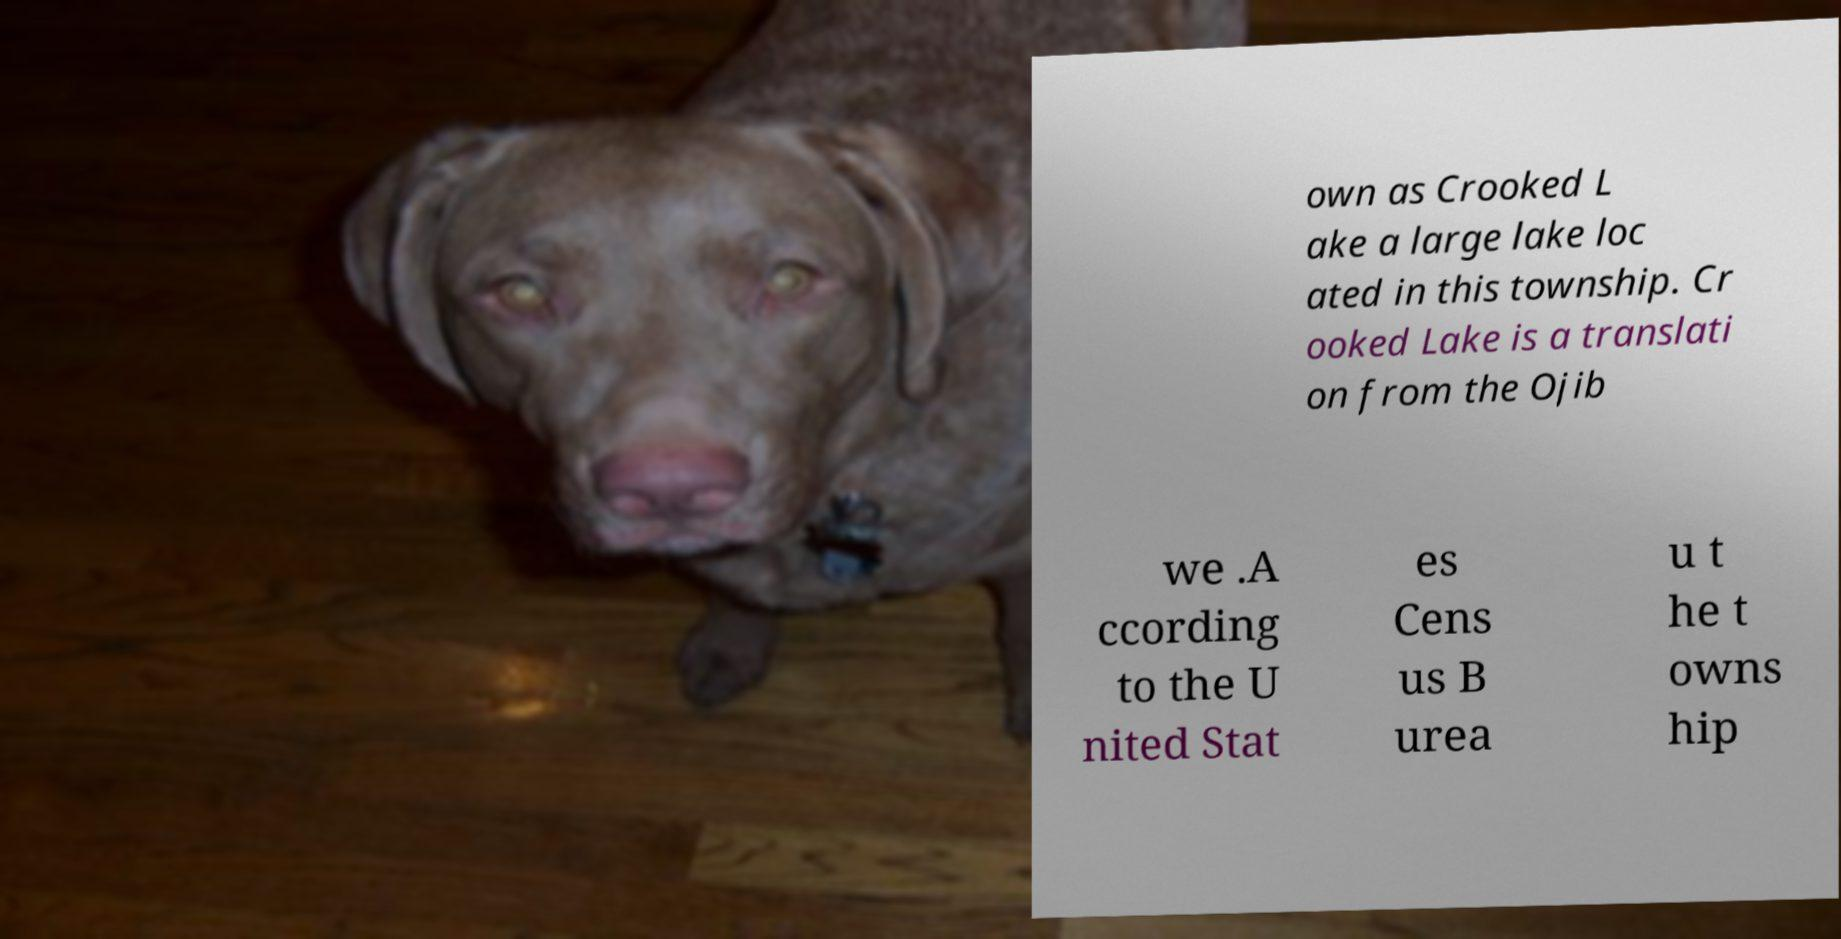Please identify and transcribe the text found in this image. own as Crooked L ake a large lake loc ated in this township. Cr ooked Lake is a translati on from the Ojib we .A ccording to the U nited Stat es Cens us B urea u t he t owns hip 